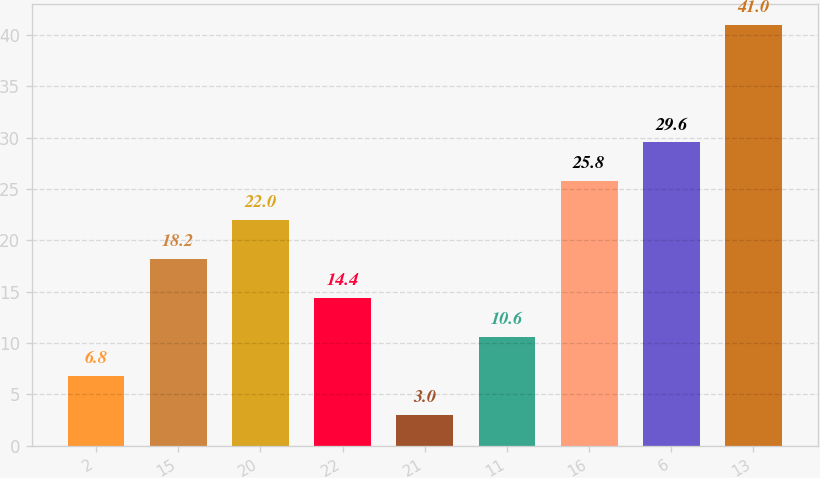Convert chart. <chart><loc_0><loc_0><loc_500><loc_500><bar_chart><fcel>2<fcel>15<fcel>20<fcel>22<fcel>21<fcel>11<fcel>16<fcel>6<fcel>13<nl><fcel>6.8<fcel>18.2<fcel>22<fcel>14.4<fcel>3<fcel>10.6<fcel>25.8<fcel>29.6<fcel>41<nl></chart> 